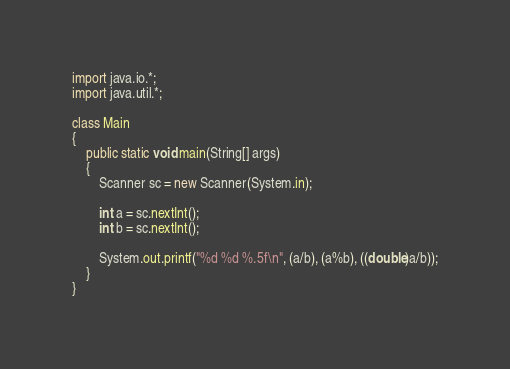Convert code to text. <code><loc_0><loc_0><loc_500><loc_500><_Java_>import java.io.*;
import java.util.*;

class Main
{
    public static void main(String[] args)
    {
        Scanner sc = new Scanner(System.in);
        
        int a = sc.nextInt();
        int b = sc.nextInt();
        
        System.out.printf("%d %d %.5f\n", (a/b), (a%b), ((double)a/b));
    }
}</code> 